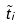<formula> <loc_0><loc_0><loc_500><loc_500>\tilde { t } _ { i }</formula> 